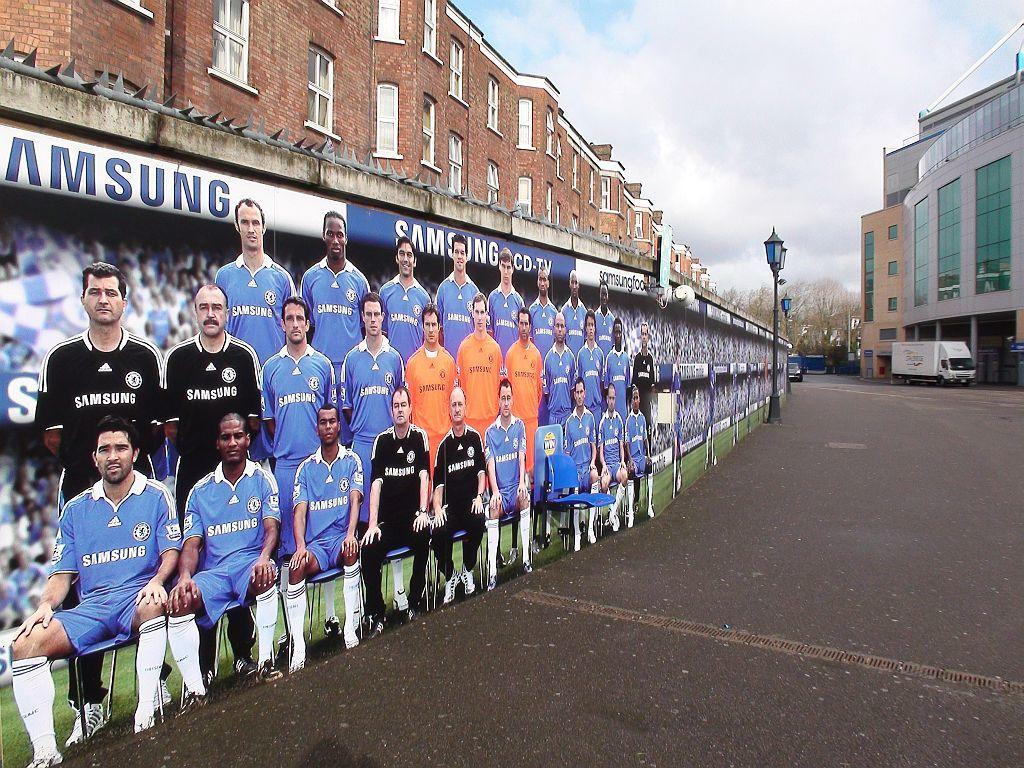<image>
Offer a succinct explanation of the picture presented. an image of athletes in black, blue, and orange sponsored by samsung. 